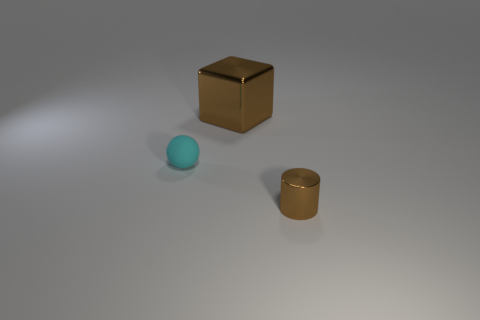Add 3 metal blocks. How many objects exist? 6 Subtract all blocks. How many objects are left? 2 Subtract 1 cyan balls. How many objects are left? 2 Subtract all metal cylinders. Subtract all small cyan objects. How many objects are left? 1 Add 2 small cyan things. How many small cyan things are left? 3 Add 3 cyan things. How many cyan things exist? 4 